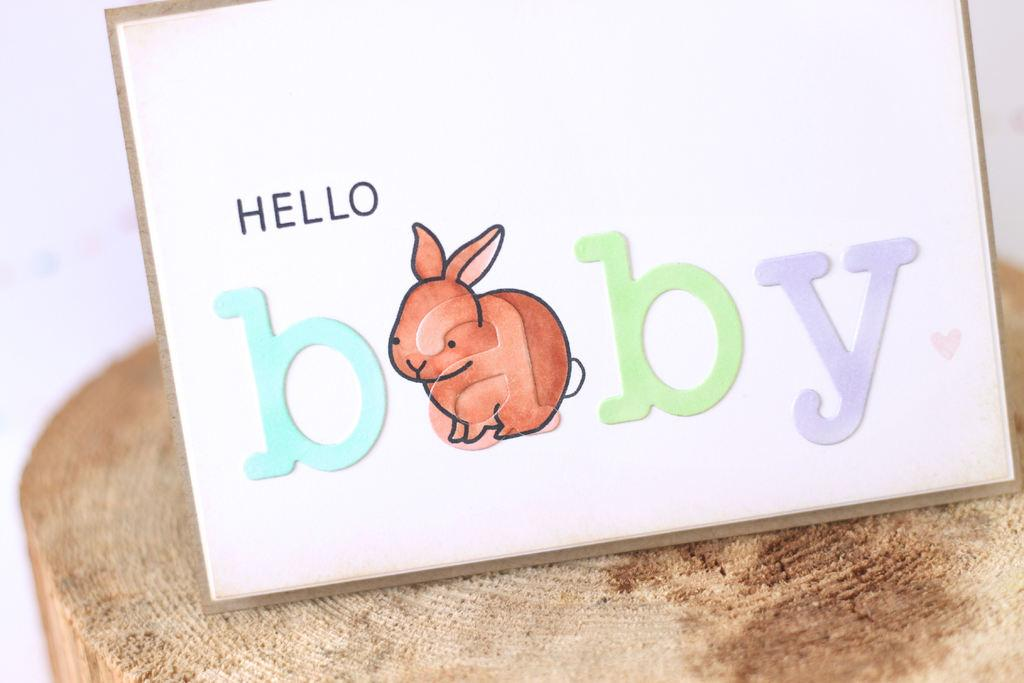What is the main object in the image? There is a painted board in the image. Where is the painted board located? The painted board is placed in the trunk of a tree. How many chairs are placed around the painted board in the image? There are no chairs present in the image; it only features a painted board placed in the trunk of a tree. 